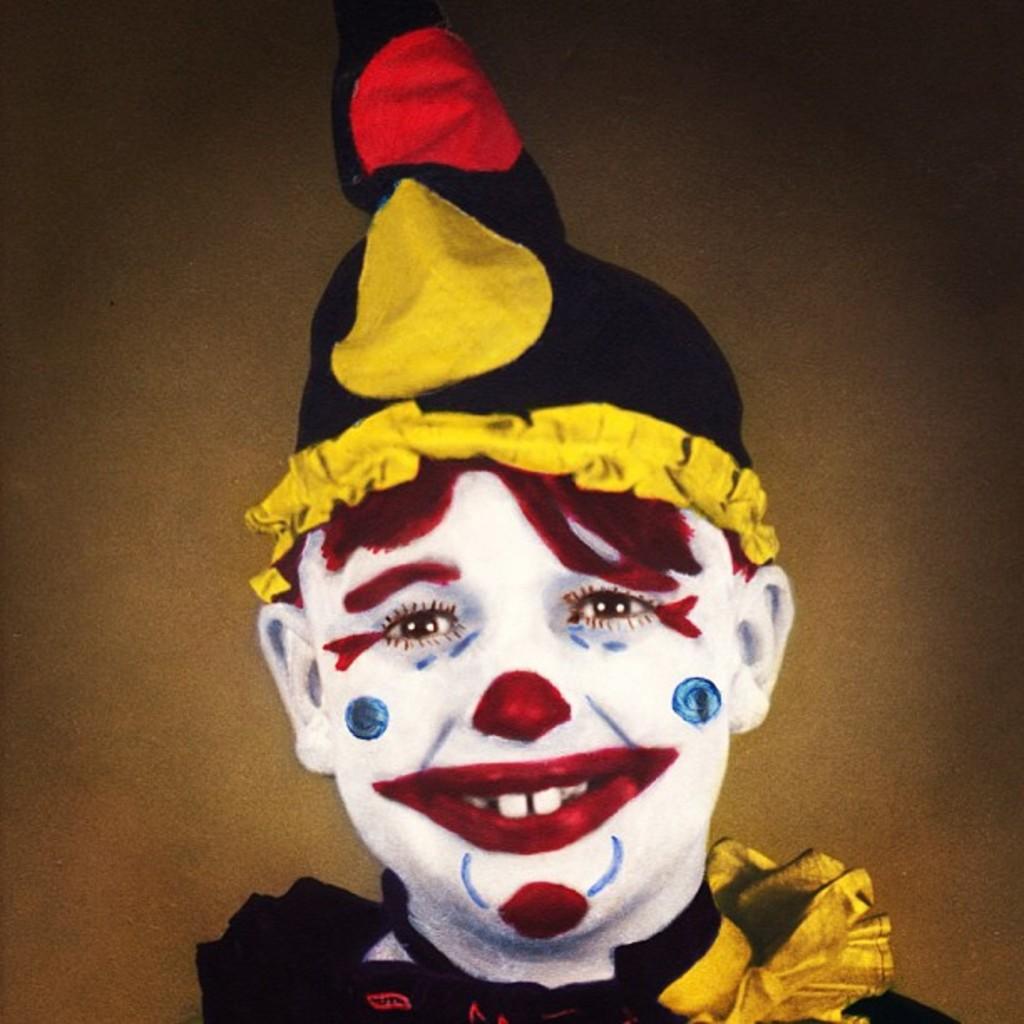Could you give a brief overview of what you see in this image? In the image there is a person with painting on the face and there is a cap on the head. And the person is smiling. 